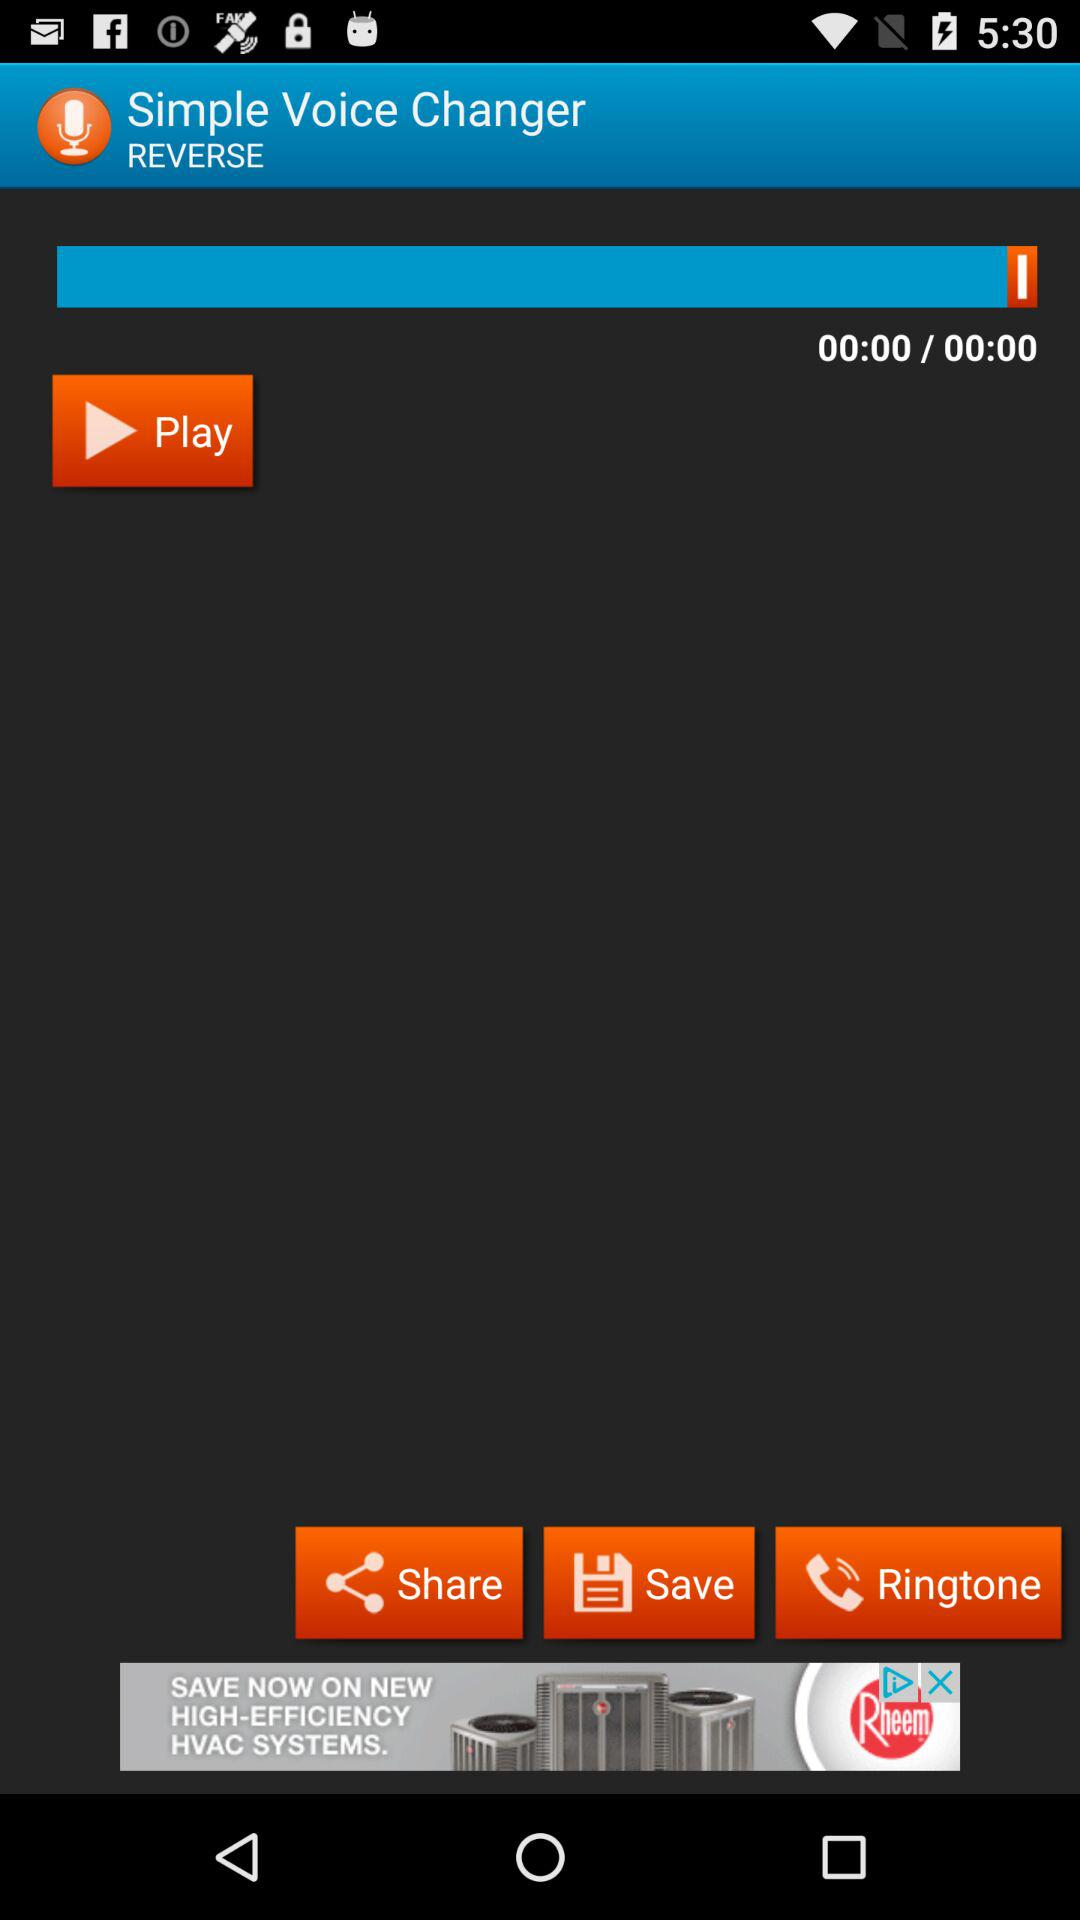What is the name of the application? The name of the application is "Simple Voice Changer". 